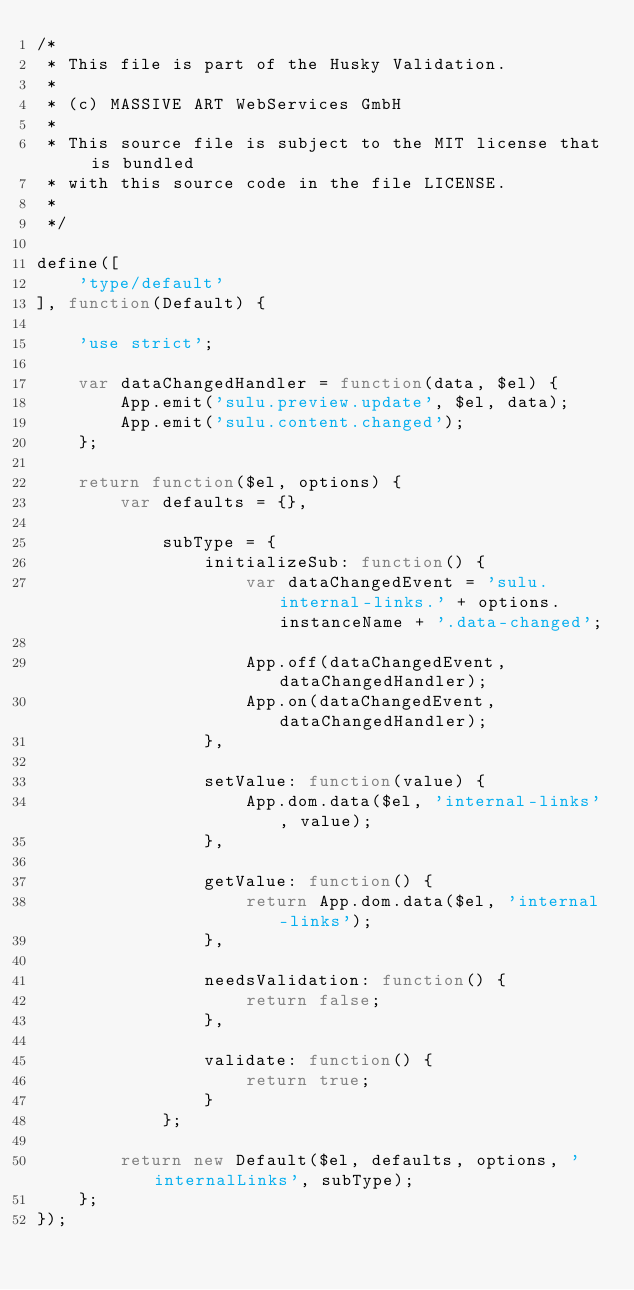Convert code to text. <code><loc_0><loc_0><loc_500><loc_500><_JavaScript_>/*
 * This file is part of the Husky Validation.
 *
 * (c) MASSIVE ART WebServices GmbH
 *
 * This source file is subject to the MIT license that is bundled
 * with this source code in the file LICENSE.
 *
 */

define([
    'type/default'
], function(Default) {

    'use strict';

    var dataChangedHandler = function(data, $el) {
        App.emit('sulu.preview.update', $el, data);
        App.emit('sulu.content.changed');
    };

    return function($el, options) {
        var defaults = {},

            subType = {
                initializeSub: function() {
                    var dataChangedEvent = 'sulu.internal-links.' + options.instanceName + '.data-changed';

                    App.off(dataChangedEvent, dataChangedHandler);
                    App.on(dataChangedEvent, dataChangedHandler);
                },

                setValue: function(value) {
                    App.dom.data($el, 'internal-links', value);
                },

                getValue: function() {
                    return App.dom.data($el, 'internal-links');
                },

                needsValidation: function() {
                    return false;
                },

                validate: function() {
                    return true;
                }
            };

        return new Default($el, defaults, options, 'internalLinks', subType);
    };
});
</code> 